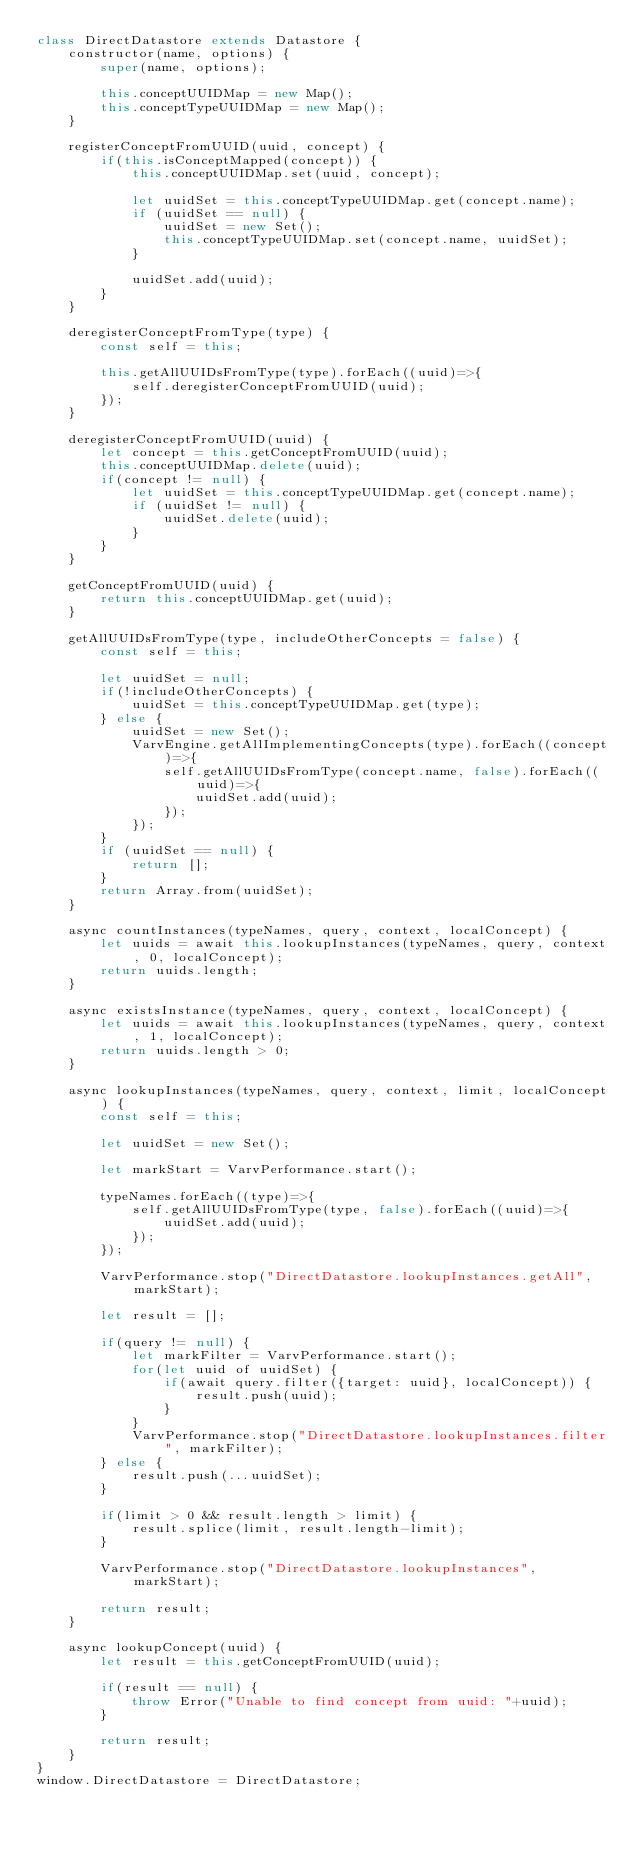<code> <loc_0><loc_0><loc_500><loc_500><_JavaScript_>class DirectDatastore extends Datastore {
    constructor(name, options) {
        super(name, options);

        this.conceptUUIDMap = new Map();
        this.conceptTypeUUIDMap = new Map();
    }

    registerConceptFromUUID(uuid, concept) {
        if(this.isConceptMapped(concept)) {
            this.conceptUUIDMap.set(uuid, concept);

            let uuidSet = this.conceptTypeUUIDMap.get(concept.name);
            if (uuidSet == null) {
                uuidSet = new Set();
                this.conceptTypeUUIDMap.set(concept.name, uuidSet);
            }

            uuidSet.add(uuid);
        }
    }

    deregisterConceptFromType(type) {
        const self = this;

        this.getAllUUIDsFromType(type).forEach((uuid)=>{
            self.deregisterConceptFromUUID(uuid);
        });
    }

    deregisterConceptFromUUID(uuid) {
        let concept = this.getConceptFromUUID(uuid);
        this.conceptUUIDMap.delete(uuid);
        if(concept != null) {
            let uuidSet = this.conceptTypeUUIDMap.get(concept.name);
            if (uuidSet != null) {
                uuidSet.delete(uuid);
            }
        }
    }

    getConceptFromUUID(uuid) {
        return this.conceptUUIDMap.get(uuid);
    }

    getAllUUIDsFromType(type, includeOtherConcepts = false) {
        const self = this;

        let uuidSet = null;
        if(!includeOtherConcepts) {
            uuidSet = this.conceptTypeUUIDMap.get(type);
        } else {
            uuidSet = new Set();
            VarvEngine.getAllImplementingConcepts(type).forEach((concept)=>{
                self.getAllUUIDsFromType(concept.name, false).forEach((uuid)=>{
                    uuidSet.add(uuid);
                });
            });
        }
        if (uuidSet == null) {
            return [];
        }
        return Array.from(uuidSet);
    }

    async countInstances(typeNames, query, context, localConcept) {
        let uuids = await this.lookupInstances(typeNames, query, context, 0, localConcept);
        return uuids.length;
    }

    async existsInstance(typeNames, query, context, localConcept) {
        let uuids = await this.lookupInstances(typeNames, query, context, 1, localConcept);
        return uuids.length > 0;
    }

    async lookupInstances(typeNames, query, context, limit, localConcept) {
        const self = this;

        let uuidSet = new Set();

        let markStart = VarvPerformance.start();

        typeNames.forEach((type)=>{
            self.getAllUUIDsFromType(type, false).forEach((uuid)=>{
                uuidSet.add(uuid);
            });
        });

        VarvPerformance.stop("DirectDatastore.lookupInstances.getAll", markStart);

        let result = [];

        if(query != null) {
            let markFilter = VarvPerformance.start();
            for(let uuid of uuidSet) {
                if(await query.filter({target: uuid}, localConcept)) {
                    result.push(uuid);
                }
            }
            VarvPerformance.stop("DirectDatastore.lookupInstances.filter", markFilter);
        } else {
            result.push(...uuidSet);
        }

        if(limit > 0 && result.length > limit) {
            result.splice(limit, result.length-limit);
        }

        VarvPerformance.stop("DirectDatastore.lookupInstances", markStart);

        return result;
    }

    async lookupConcept(uuid) {
        let result = this.getConceptFromUUID(uuid);

        if(result == null) {
            throw Error("Unable to find concept from uuid: "+uuid);
        }

        return result;
    }
}
window.DirectDatastore = DirectDatastore;
</code> 